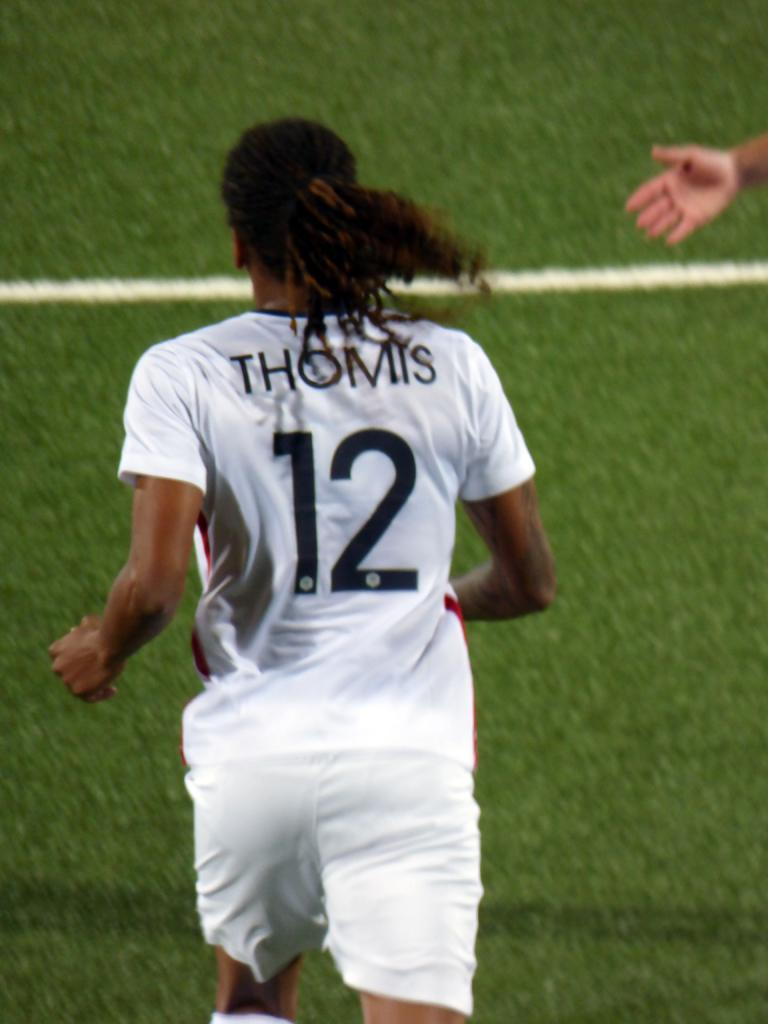<image>
Offer a succinct explanation of the picture presented. A person wearing a Thomis 12 jersey runs across a field. 